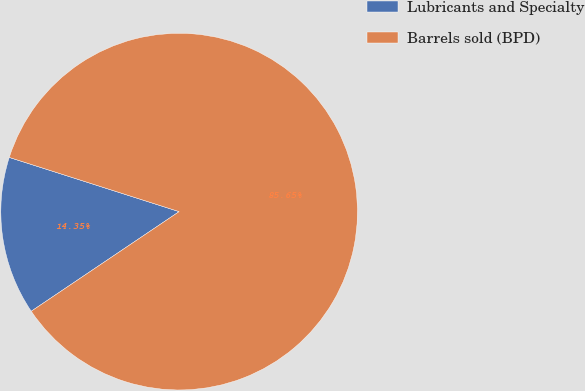Convert chart. <chart><loc_0><loc_0><loc_500><loc_500><pie_chart><fcel>Lubricants and Specialty<fcel>Barrels sold (BPD)<nl><fcel>14.35%<fcel>85.65%<nl></chart> 